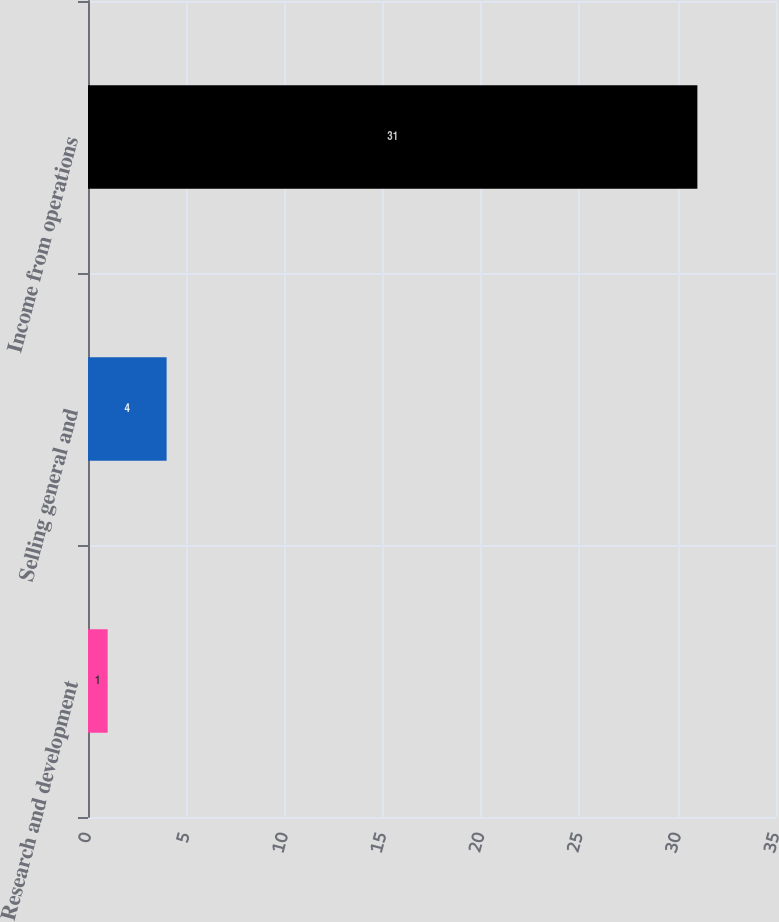<chart> <loc_0><loc_0><loc_500><loc_500><bar_chart><fcel>Research and development<fcel>Selling general and<fcel>Income from operations<nl><fcel>1<fcel>4<fcel>31<nl></chart> 